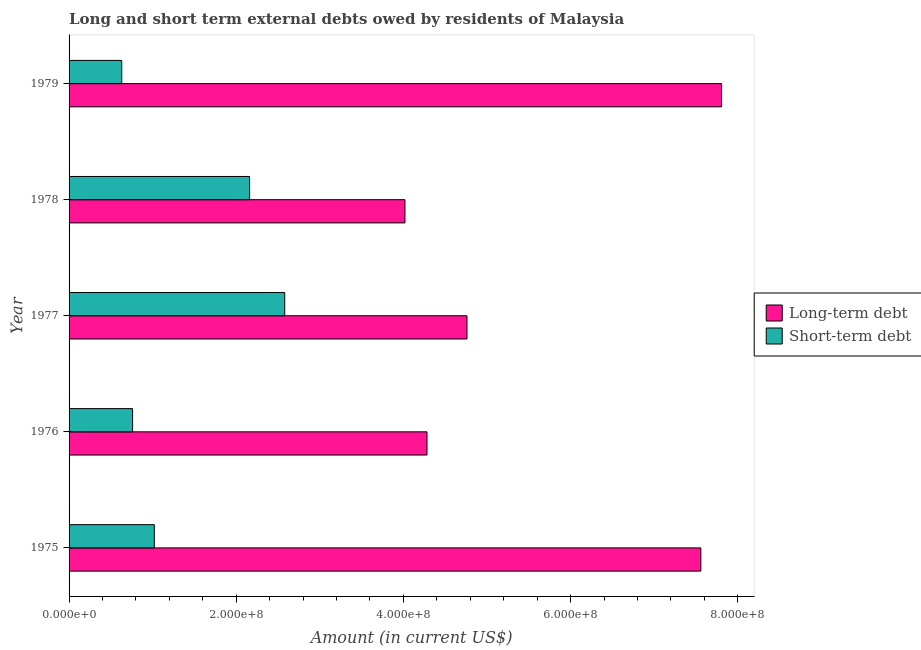How many different coloured bars are there?
Your response must be concise. 2. Are the number of bars on each tick of the Y-axis equal?
Make the answer very short. Yes. How many bars are there on the 3rd tick from the top?
Give a very brief answer. 2. How many bars are there on the 2nd tick from the bottom?
Your response must be concise. 2. What is the label of the 2nd group of bars from the top?
Ensure brevity in your answer.  1978. In how many cases, is the number of bars for a given year not equal to the number of legend labels?
Your answer should be compact. 0. What is the long-term debts owed by residents in 1979?
Offer a terse response. 7.81e+08. Across all years, what is the maximum long-term debts owed by residents?
Offer a terse response. 7.81e+08. Across all years, what is the minimum long-term debts owed by residents?
Provide a short and direct response. 4.02e+08. In which year was the long-term debts owed by residents maximum?
Ensure brevity in your answer.  1979. In which year was the long-term debts owed by residents minimum?
Make the answer very short. 1978. What is the total long-term debts owed by residents in the graph?
Offer a terse response. 2.84e+09. What is the difference between the short-term debts owed by residents in 1975 and that in 1976?
Ensure brevity in your answer.  2.60e+07. What is the difference between the long-term debts owed by residents in 1976 and the short-term debts owed by residents in 1977?
Provide a short and direct response. 1.70e+08. What is the average short-term debts owed by residents per year?
Give a very brief answer. 1.43e+08. In the year 1977, what is the difference between the long-term debts owed by residents and short-term debts owed by residents?
Provide a succinct answer. 2.18e+08. What is the ratio of the long-term debts owed by residents in 1976 to that in 1978?
Your answer should be compact. 1.07. Is the difference between the long-term debts owed by residents in 1975 and 1977 greater than the difference between the short-term debts owed by residents in 1975 and 1977?
Make the answer very short. Yes. What is the difference between the highest and the second highest short-term debts owed by residents?
Keep it short and to the point. 4.20e+07. What is the difference between the highest and the lowest long-term debts owed by residents?
Provide a short and direct response. 3.79e+08. In how many years, is the short-term debts owed by residents greater than the average short-term debts owed by residents taken over all years?
Your response must be concise. 2. Is the sum of the short-term debts owed by residents in 1975 and 1976 greater than the maximum long-term debts owed by residents across all years?
Provide a succinct answer. No. What does the 1st bar from the top in 1976 represents?
Provide a succinct answer. Short-term debt. What does the 1st bar from the bottom in 1978 represents?
Your answer should be very brief. Long-term debt. How many bars are there?
Your answer should be compact. 10. How many years are there in the graph?
Your answer should be very brief. 5. Does the graph contain any zero values?
Ensure brevity in your answer.  No. Where does the legend appear in the graph?
Keep it short and to the point. Center right. How many legend labels are there?
Make the answer very short. 2. What is the title of the graph?
Your answer should be very brief. Long and short term external debts owed by residents of Malaysia. What is the label or title of the Y-axis?
Make the answer very short. Year. What is the Amount (in current US$) of Long-term debt in 1975?
Provide a succinct answer. 7.56e+08. What is the Amount (in current US$) in Short-term debt in 1975?
Provide a succinct answer. 1.02e+08. What is the Amount (in current US$) of Long-term debt in 1976?
Your answer should be compact. 4.28e+08. What is the Amount (in current US$) in Short-term debt in 1976?
Keep it short and to the point. 7.60e+07. What is the Amount (in current US$) in Long-term debt in 1977?
Your answer should be compact. 4.76e+08. What is the Amount (in current US$) of Short-term debt in 1977?
Provide a succinct answer. 2.58e+08. What is the Amount (in current US$) in Long-term debt in 1978?
Make the answer very short. 4.02e+08. What is the Amount (in current US$) in Short-term debt in 1978?
Provide a succinct answer. 2.16e+08. What is the Amount (in current US$) of Long-term debt in 1979?
Keep it short and to the point. 7.81e+08. What is the Amount (in current US$) of Short-term debt in 1979?
Provide a short and direct response. 6.30e+07. Across all years, what is the maximum Amount (in current US$) of Long-term debt?
Keep it short and to the point. 7.81e+08. Across all years, what is the maximum Amount (in current US$) of Short-term debt?
Make the answer very short. 2.58e+08. Across all years, what is the minimum Amount (in current US$) of Long-term debt?
Keep it short and to the point. 4.02e+08. Across all years, what is the minimum Amount (in current US$) of Short-term debt?
Provide a short and direct response. 6.30e+07. What is the total Amount (in current US$) of Long-term debt in the graph?
Your answer should be very brief. 2.84e+09. What is the total Amount (in current US$) of Short-term debt in the graph?
Your answer should be very brief. 7.15e+08. What is the difference between the Amount (in current US$) of Long-term debt in 1975 and that in 1976?
Your answer should be compact. 3.28e+08. What is the difference between the Amount (in current US$) of Short-term debt in 1975 and that in 1976?
Give a very brief answer. 2.60e+07. What is the difference between the Amount (in current US$) in Long-term debt in 1975 and that in 1977?
Provide a short and direct response. 2.80e+08. What is the difference between the Amount (in current US$) in Short-term debt in 1975 and that in 1977?
Ensure brevity in your answer.  -1.56e+08. What is the difference between the Amount (in current US$) of Long-term debt in 1975 and that in 1978?
Give a very brief answer. 3.54e+08. What is the difference between the Amount (in current US$) of Short-term debt in 1975 and that in 1978?
Make the answer very short. -1.14e+08. What is the difference between the Amount (in current US$) of Long-term debt in 1975 and that in 1979?
Make the answer very short. -2.48e+07. What is the difference between the Amount (in current US$) in Short-term debt in 1975 and that in 1979?
Your response must be concise. 3.90e+07. What is the difference between the Amount (in current US$) of Long-term debt in 1976 and that in 1977?
Provide a succinct answer. -4.78e+07. What is the difference between the Amount (in current US$) in Short-term debt in 1976 and that in 1977?
Give a very brief answer. -1.82e+08. What is the difference between the Amount (in current US$) in Long-term debt in 1976 and that in 1978?
Offer a terse response. 2.64e+07. What is the difference between the Amount (in current US$) in Short-term debt in 1976 and that in 1978?
Your answer should be compact. -1.40e+08. What is the difference between the Amount (in current US$) in Long-term debt in 1976 and that in 1979?
Make the answer very short. -3.52e+08. What is the difference between the Amount (in current US$) of Short-term debt in 1976 and that in 1979?
Your answer should be very brief. 1.30e+07. What is the difference between the Amount (in current US$) of Long-term debt in 1977 and that in 1978?
Offer a very short reply. 7.42e+07. What is the difference between the Amount (in current US$) in Short-term debt in 1977 and that in 1978?
Provide a succinct answer. 4.20e+07. What is the difference between the Amount (in current US$) in Long-term debt in 1977 and that in 1979?
Ensure brevity in your answer.  -3.05e+08. What is the difference between the Amount (in current US$) of Short-term debt in 1977 and that in 1979?
Provide a succinct answer. 1.95e+08. What is the difference between the Amount (in current US$) of Long-term debt in 1978 and that in 1979?
Your answer should be very brief. -3.79e+08. What is the difference between the Amount (in current US$) of Short-term debt in 1978 and that in 1979?
Your answer should be very brief. 1.53e+08. What is the difference between the Amount (in current US$) in Long-term debt in 1975 and the Amount (in current US$) in Short-term debt in 1976?
Offer a terse response. 6.80e+08. What is the difference between the Amount (in current US$) in Long-term debt in 1975 and the Amount (in current US$) in Short-term debt in 1977?
Give a very brief answer. 4.98e+08. What is the difference between the Amount (in current US$) in Long-term debt in 1975 and the Amount (in current US$) in Short-term debt in 1978?
Ensure brevity in your answer.  5.40e+08. What is the difference between the Amount (in current US$) in Long-term debt in 1975 and the Amount (in current US$) in Short-term debt in 1979?
Your answer should be compact. 6.93e+08. What is the difference between the Amount (in current US$) of Long-term debt in 1976 and the Amount (in current US$) of Short-term debt in 1977?
Your answer should be very brief. 1.70e+08. What is the difference between the Amount (in current US$) in Long-term debt in 1976 and the Amount (in current US$) in Short-term debt in 1978?
Offer a terse response. 2.12e+08. What is the difference between the Amount (in current US$) in Long-term debt in 1976 and the Amount (in current US$) in Short-term debt in 1979?
Make the answer very short. 3.65e+08. What is the difference between the Amount (in current US$) of Long-term debt in 1977 and the Amount (in current US$) of Short-term debt in 1978?
Ensure brevity in your answer.  2.60e+08. What is the difference between the Amount (in current US$) in Long-term debt in 1977 and the Amount (in current US$) in Short-term debt in 1979?
Keep it short and to the point. 4.13e+08. What is the difference between the Amount (in current US$) in Long-term debt in 1978 and the Amount (in current US$) in Short-term debt in 1979?
Your response must be concise. 3.39e+08. What is the average Amount (in current US$) of Long-term debt per year?
Offer a very short reply. 5.69e+08. What is the average Amount (in current US$) in Short-term debt per year?
Offer a very short reply. 1.43e+08. In the year 1975, what is the difference between the Amount (in current US$) in Long-term debt and Amount (in current US$) in Short-term debt?
Make the answer very short. 6.54e+08. In the year 1976, what is the difference between the Amount (in current US$) of Long-term debt and Amount (in current US$) of Short-term debt?
Keep it short and to the point. 3.52e+08. In the year 1977, what is the difference between the Amount (in current US$) in Long-term debt and Amount (in current US$) in Short-term debt?
Your response must be concise. 2.18e+08. In the year 1978, what is the difference between the Amount (in current US$) of Long-term debt and Amount (in current US$) of Short-term debt?
Provide a short and direct response. 1.86e+08. In the year 1979, what is the difference between the Amount (in current US$) of Long-term debt and Amount (in current US$) of Short-term debt?
Keep it short and to the point. 7.18e+08. What is the ratio of the Amount (in current US$) in Long-term debt in 1975 to that in 1976?
Offer a terse response. 1.77. What is the ratio of the Amount (in current US$) of Short-term debt in 1975 to that in 1976?
Offer a terse response. 1.34. What is the ratio of the Amount (in current US$) in Long-term debt in 1975 to that in 1977?
Provide a short and direct response. 1.59. What is the ratio of the Amount (in current US$) in Short-term debt in 1975 to that in 1977?
Provide a short and direct response. 0.4. What is the ratio of the Amount (in current US$) in Long-term debt in 1975 to that in 1978?
Offer a very short reply. 1.88. What is the ratio of the Amount (in current US$) of Short-term debt in 1975 to that in 1978?
Your response must be concise. 0.47. What is the ratio of the Amount (in current US$) in Long-term debt in 1975 to that in 1979?
Give a very brief answer. 0.97. What is the ratio of the Amount (in current US$) of Short-term debt in 1975 to that in 1979?
Provide a succinct answer. 1.62. What is the ratio of the Amount (in current US$) in Long-term debt in 1976 to that in 1977?
Provide a succinct answer. 0.9. What is the ratio of the Amount (in current US$) in Short-term debt in 1976 to that in 1977?
Provide a succinct answer. 0.29. What is the ratio of the Amount (in current US$) of Long-term debt in 1976 to that in 1978?
Offer a very short reply. 1.07. What is the ratio of the Amount (in current US$) in Short-term debt in 1976 to that in 1978?
Provide a succinct answer. 0.35. What is the ratio of the Amount (in current US$) in Long-term debt in 1976 to that in 1979?
Make the answer very short. 0.55. What is the ratio of the Amount (in current US$) in Short-term debt in 1976 to that in 1979?
Keep it short and to the point. 1.21. What is the ratio of the Amount (in current US$) of Long-term debt in 1977 to that in 1978?
Your answer should be very brief. 1.18. What is the ratio of the Amount (in current US$) in Short-term debt in 1977 to that in 1978?
Provide a succinct answer. 1.19. What is the ratio of the Amount (in current US$) of Long-term debt in 1977 to that in 1979?
Your answer should be compact. 0.61. What is the ratio of the Amount (in current US$) in Short-term debt in 1977 to that in 1979?
Offer a terse response. 4.1. What is the ratio of the Amount (in current US$) of Long-term debt in 1978 to that in 1979?
Your answer should be very brief. 0.51. What is the ratio of the Amount (in current US$) of Short-term debt in 1978 to that in 1979?
Provide a short and direct response. 3.43. What is the difference between the highest and the second highest Amount (in current US$) of Long-term debt?
Make the answer very short. 2.48e+07. What is the difference between the highest and the second highest Amount (in current US$) of Short-term debt?
Your answer should be compact. 4.20e+07. What is the difference between the highest and the lowest Amount (in current US$) in Long-term debt?
Make the answer very short. 3.79e+08. What is the difference between the highest and the lowest Amount (in current US$) of Short-term debt?
Your answer should be compact. 1.95e+08. 